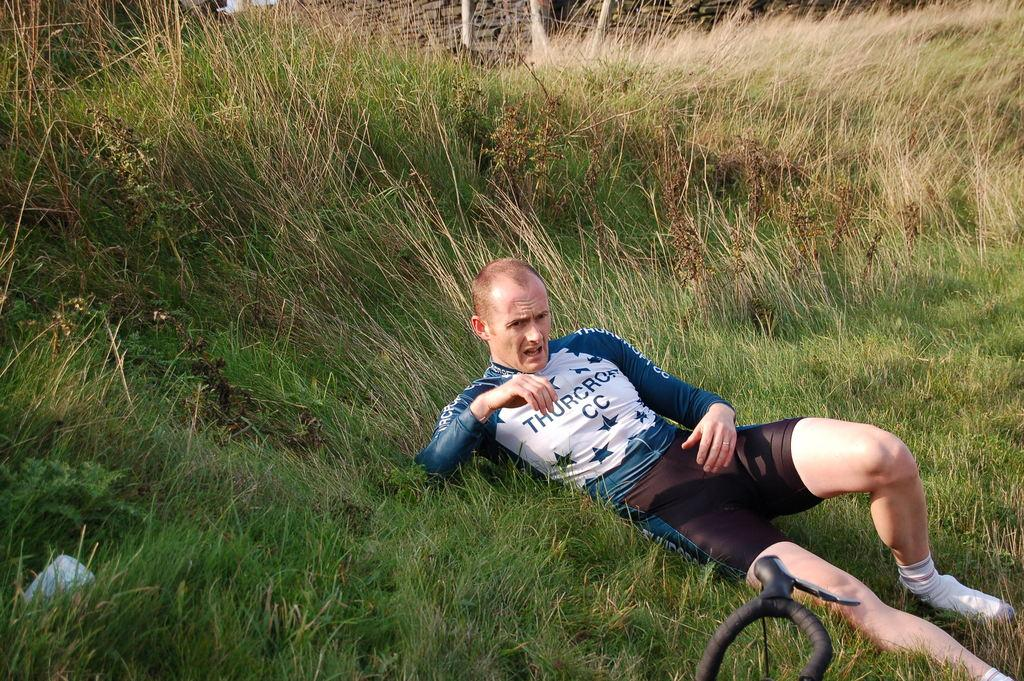Who is present in the image? There is a man in the image. What is the man's position in the image? The man is lying on a grassland. What type of metal is the man using to increase his comfort while lying on the grassland? There is no metal present in the image, and the man is not using any metal to increase his comfort. 